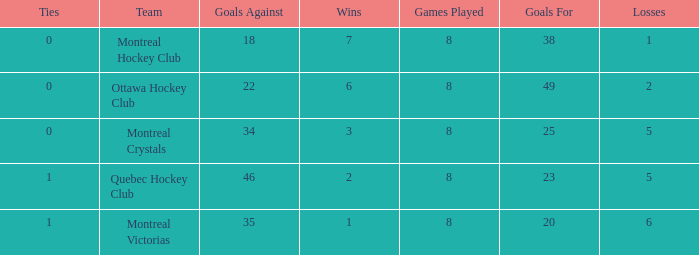Write the full table. {'header': ['Ties', 'Team', 'Goals Against', 'Wins', 'Games Played', 'Goals For', 'Losses'], 'rows': [['0', 'Montreal Hockey Club', '18', '7', '8', '38', '1'], ['0', 'Ottawa Hockey Club', '22', '6', '8', '49', '2'], ['0', 'Montreal Crystals', '34', '3', '8', '25', '5'], ['1', 'Quebec Hockey Club', '46', '2', '8', '23', '5'], ['1', 'Montreal Victorias', '35', '1', '8', '20', '6']]} Calculate the sum of losses when the goals against is below 34 and the games played are less than 8. None. 